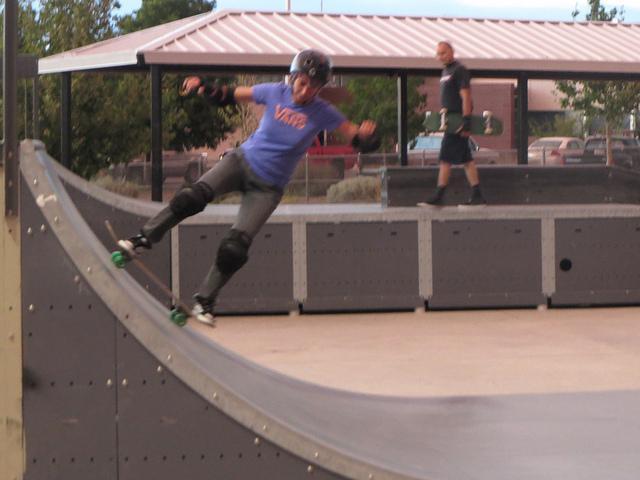On the front man what is most protected?
Select the accurate answer and provide explanation: 'Answer: answer
Rationale: rationale.'
Options: Knees, shins, chest, nose. Answer: knees.
Rationale: The man is wearing large kneepads. 